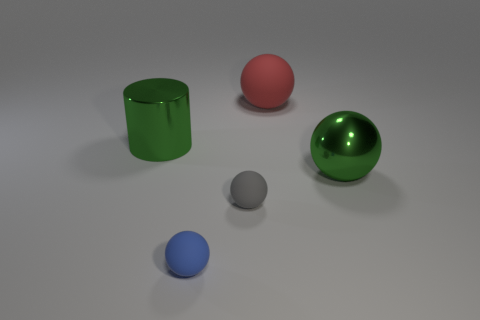Subtract all yellow spheres. Subtract all cyan cubes. How many spheres are left? 4 Add 1 big green things. How many objects exist? 6 Subtract all balls. How many objects are left? 1 Add 2 large green balls. How many large green balls exist? 3 Subtract 0 purple balls. How many objects are left? 5 Subtract all green objects. Subtract all metallic cylinders. How many objects are left? 2 Add 2 green cylinders. How many green cylinders are left? 3 